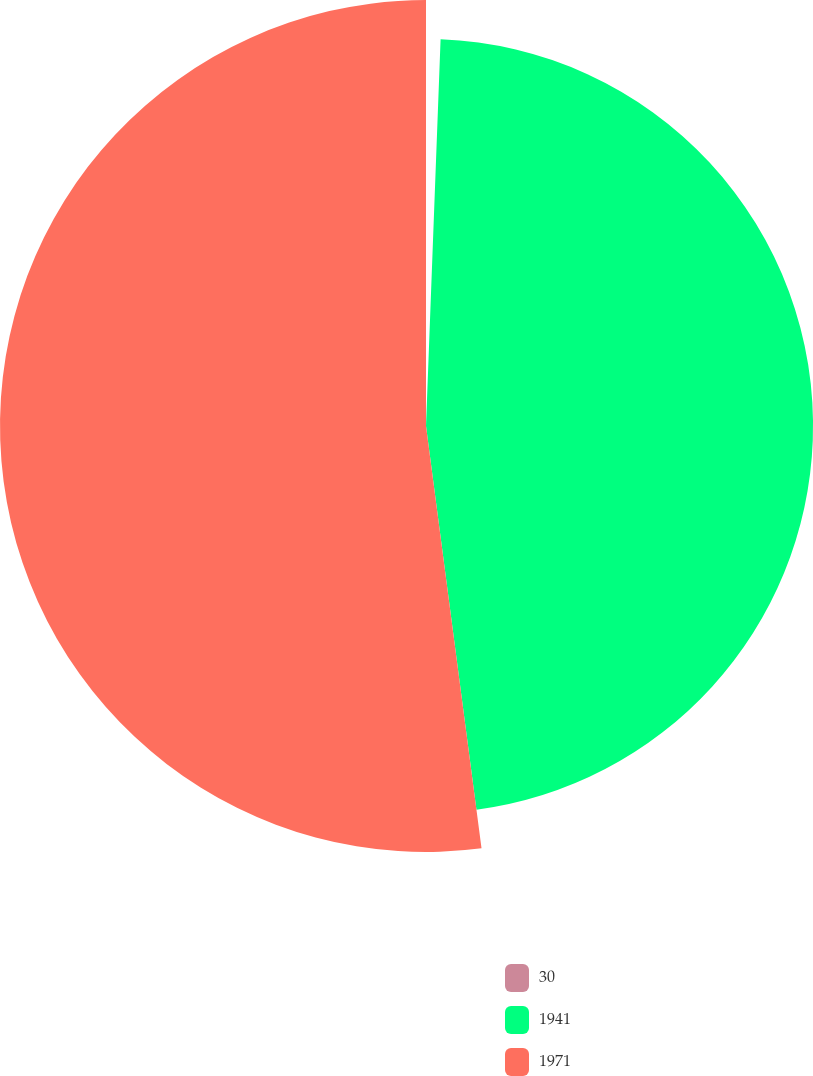Convert chart. <chart><loc_0><loc_0><loc_500><loc_500><pie_chart><fcel>30<fcel>1941<fcel>1971<nl><fcel>0.6%<fcel>47.32%<fcel>52.08%<nl></chart> 